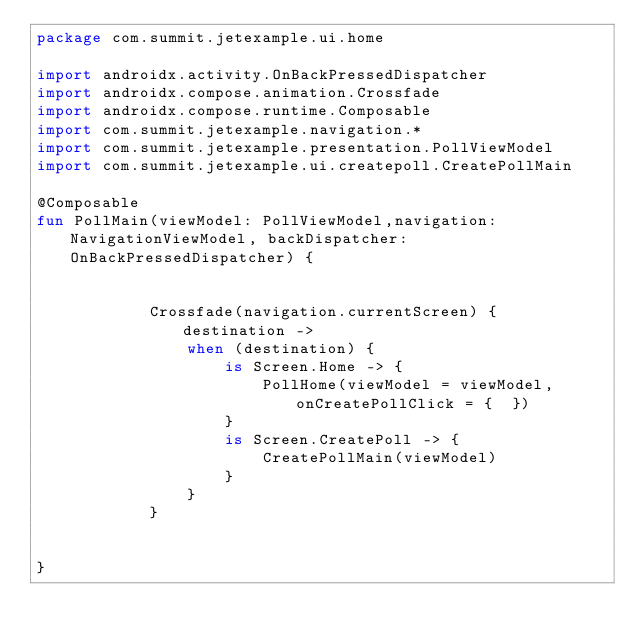<code> <loc_0><loc_0><loc_500><loc_500><_Kotlin_>package com.summit.jetexample.ui.home

import androidx.activity.OnBackPressedDispatcher
import androidx.compose.animation.Crossfade
import androidx.compose.runtime.Composable
import com.summit.jetexample.navigation.*
import com.summit.jetexample.presentation.PollViewModel
import com.summit.jetexample.ui.createpoll.CreatePollMain

@Composable
fun PollMain(viewModel: PollViewModel,navigation:NavigationViewModel, backDispatcher: OnBackPressedDispatcher) {


            Crossfade(navigation.currentScreen) { destination ->
                when (destination) {
                    is Screen.Home -> {
                        PollHome(viewModel = viewModel,onCreatePollClick = {  })
                    }
                    is Screen.CreatePoll -> {
                        CreatePollMain(viewModel)
                    }
                }
            }


}</code> 